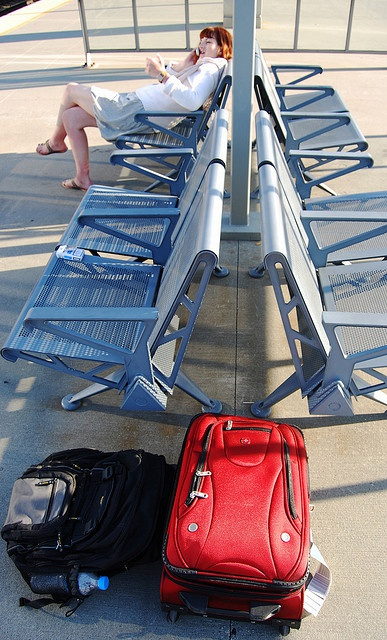Describe the objects in this image and their specific colors. I can see suitcase in black, salmon, brown, and red tones, bench in black, gray, and blue tones, backpack in black, gray, darkgray, and navy tones, bench in black, darkgray, lightgray, and gray tones, and people in black, lightgray, darkgray, and brown tones in this image. 